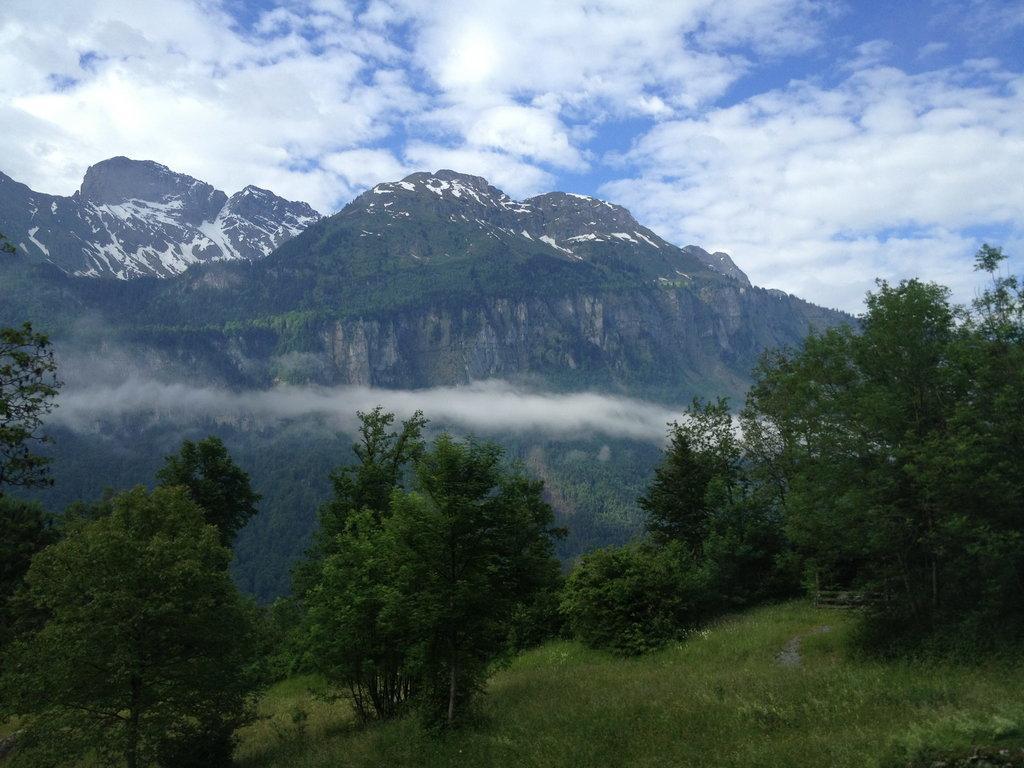Could you give a brief overview of what you see in this image? In this image we can see some trees, grass and in the background of the image there are some mountains, clouds and blue color sky. 